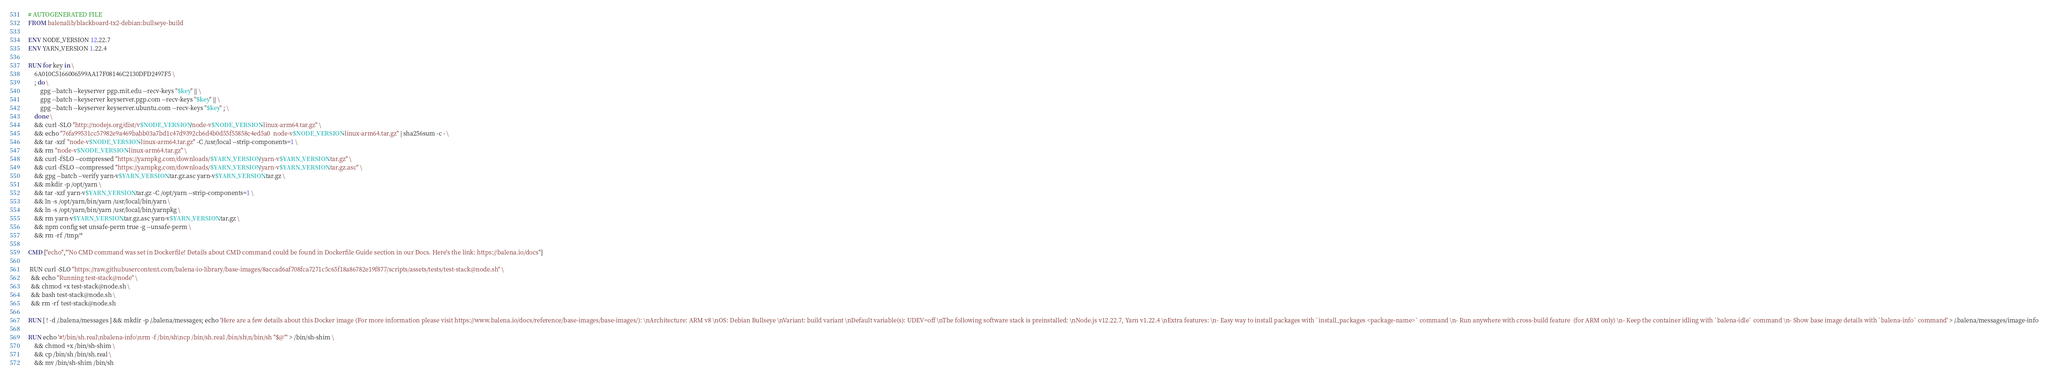Convert code to text. <code><loc_0><loc_0><loc_500><loc_500><_Dockerfile_># AUTOGENERATED FILE
FROM balenalib/blackboard-tx2-debian:bullseye-build

ENV NODE_VERSION 12.22.7
ENV YARN_VERSION 1.22.4

RUN for key in \
	6A010C5166006599AA17F08146C2130DFD2497F5 \
	; do \
		gpg --batch --keyserver pgp.mit.edu --recv-keys "$key" || \
		gpg --batch --keyserver keyserver.pgp.com --recv-keys "$key" || \
		gpg --batch --keyserver keyserver.ubuntu.com --recv-keys "$key" ; \
	done \
	&& curl -SLO "http://nodejs.org/dist/v$NODE_VERSION/node-v$NODE_VERSION-linux-arm64.tar.gz" \
	&& echo "76fa99531cc57982e9a469babb03a7bd1c47d9392cb6d4b0d55f55858c4ed5a0  node-v$NODE_VERSION-linux-arm64.tar.gz" | sha256sum -c - \
	&& tar -xzf "node-v$NODE_VERSION-linux-arm64.tar.gz" -C /usr/local --strip-components=1 \
	&& rm "node-v$NODE_VERSION-linux-arm64.tar.gz" \
	&& curl -fSLO --compressed "https://yarnpkg.com/downloads/$YARN_VERSION/yarn-v$YARN_VERSION.tar.gz" \
	&& curl -fSLO --compressed "https://yarnpkg.com/downloads/$YARN_VERSION/yarn-v$YARN_VERSION.tar.gz.asc" \
	&& gpg --batch --verify yarn-v$YARN_VERSION.tar.gz.asc yarn-v$YARN_VERSION.tar.gz \
	&& mkdir -p /opt/yarn \
	&& tar -xzf yarn-v$YARN_VERSION.tar.gz -C /opt/yarn --strip-components=1 \
	&& ln -s /opt/yarn/bin/yarn /usr/local/bin/yarn \
	&& ln -s /opt/yarn/bin/yarn /usr/local/bin/yarnpkg \
	&& rm yarn-v$YARN_VERSION.tar.gz.asc yarn-v$YARN_VERSION.tar.gz \
	&& npm config set unsafe-perm true -g --unsafe-perm \
	&& rm -rf /tmp/*

CMD ["echo","'No CMD command was set in Dockerfile! Details about CMD command could be found in Dockerfile Guide section in our Docs. Here's the link: https://balena.io/docs"]

 RUN curl -SLO "https://raw.githubusercontent.com/balena-io-library/base-images/8accad6af708fca7271c5c65f18a86782e19f877/scripts/assets/tests/test-stack@node.sh" \
  && echo "Running test-stack@node" \
  && chmod +x test-stack@node.sh \
  && bash test-stack@node.sh \
  && rm -rf test-stack@node.sh 

RUN [ ! -d /.balena/messages ] && mkdir -p /.balena/messages; echo 'Here are a few details about this Docker image (For more information please visit https://www.balena.io/docs/reference/base-images/base-images/): \nArchitecture: ARM v8 \nOS: Debian Bullseye \nVariant: build variant \nDefault variable(s): UDEV=off \nThe following software stack is preinstalled: \nNode.js v12.22.7, Yarn v1.22.4 \nExtra features: \n- Easy way to install packages with `install_packages <package-name>` command \n- Run anywhere with cross-build feature  (for ARM only) \n- Keep the container idling with `balena-idle` command \n- Show base image details with `balena-info` command' > /.balena/messages/image-info

RUN echo '#!/bin/sh.real\nbalena-info\nrm -f /bin/sh\ncp /bin/sh.real /bin/sh\n/bin/sh "$@"' > /bin/sh-shim \
	&& chmod +x /bin/sh-shim \
	&& cp /bin/sh /bin/sh.real \
	&& mv /bin/sh-shim /bin/sh</code> 